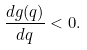<formula> <loc_0><loc_0><loc_500><loc_500>\frac { d g ( q ) } { d q } < 0 .</formula> 